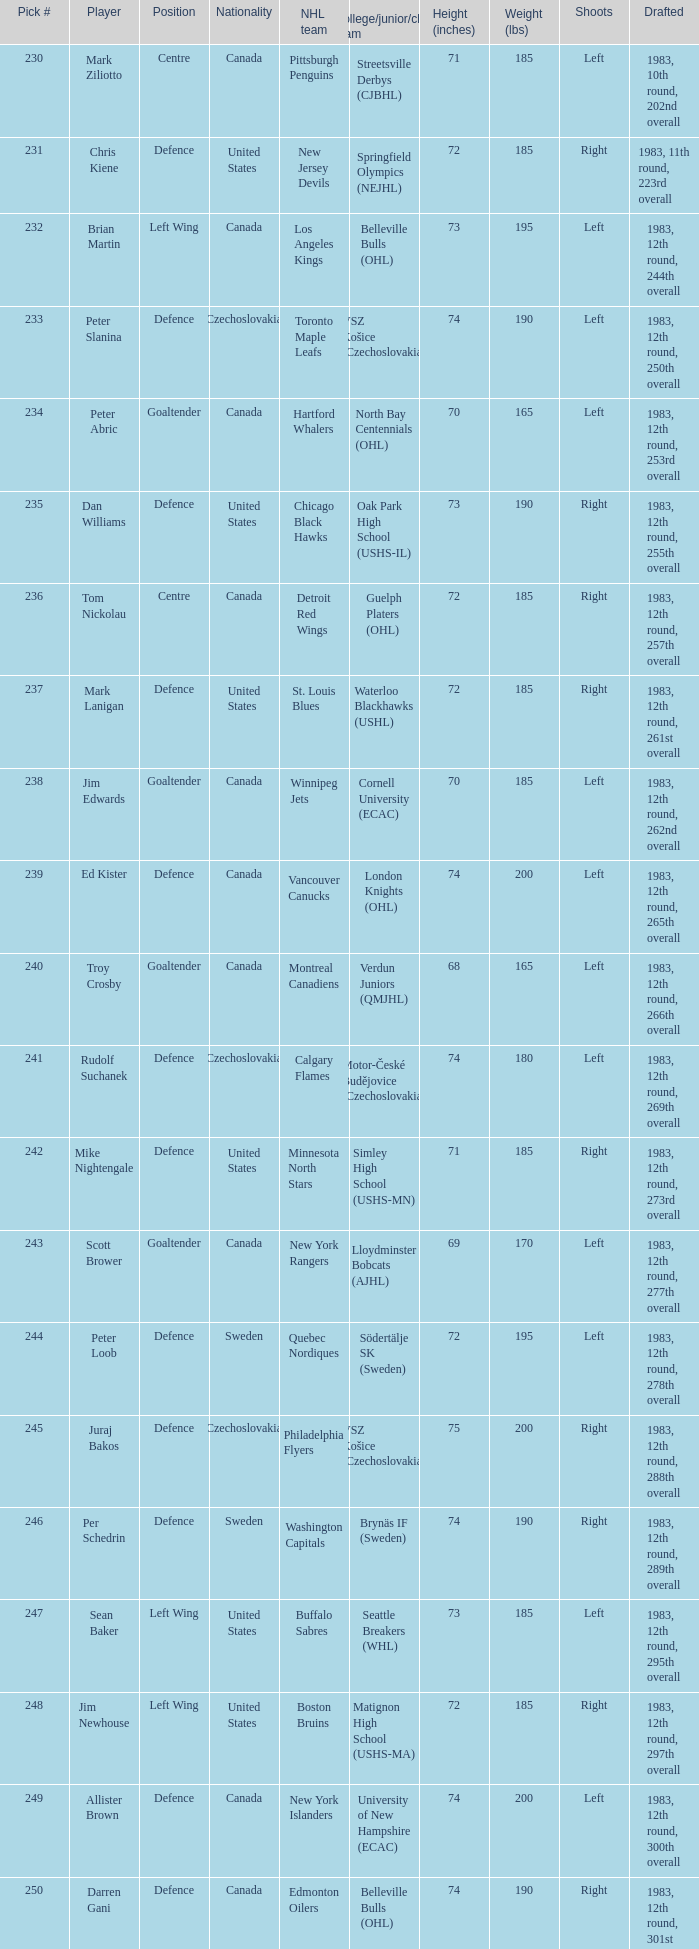To which organziation does the  winnipeg jets belong to? Cornell University (ECAC). 